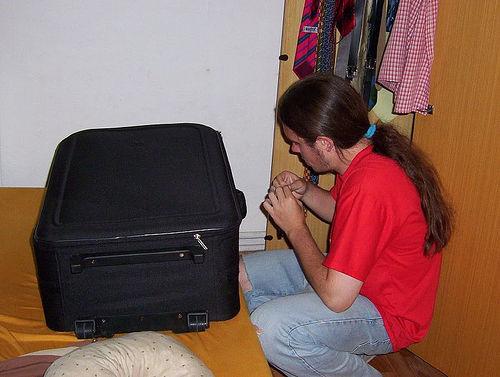What color is his top?
Be succinct. Red. Is he trying to close his suitcase?
Be succinct. No. What is in the suitcase?
Quick response, please. Clothes. Is there a mirror in the photo?
Give a very brief answer. No. Is this a young adult?
Concise answer only. Yes. Are his jeans ripped?
Keep it brief. Yes. Where is the orange?
Write a very short answer. No orange. What color is the luggage?
Keep it brief. Black. 